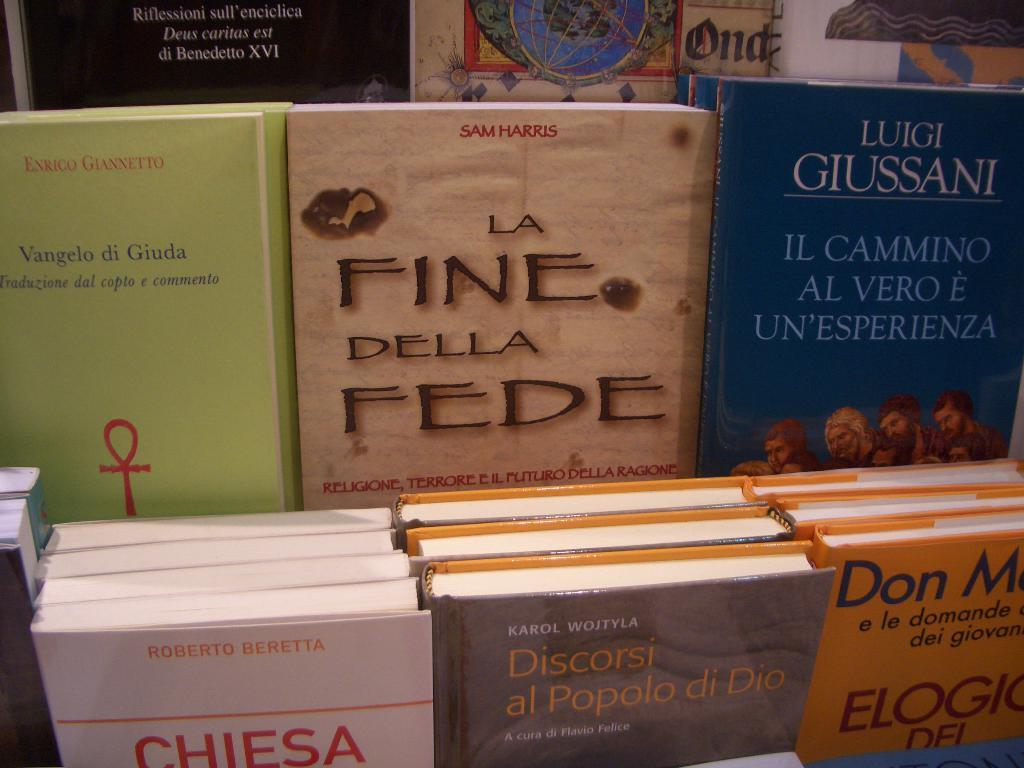<image>
Write a terse but informative summary of the picture. Books such as La Fine Della Fede are on display at a store. 